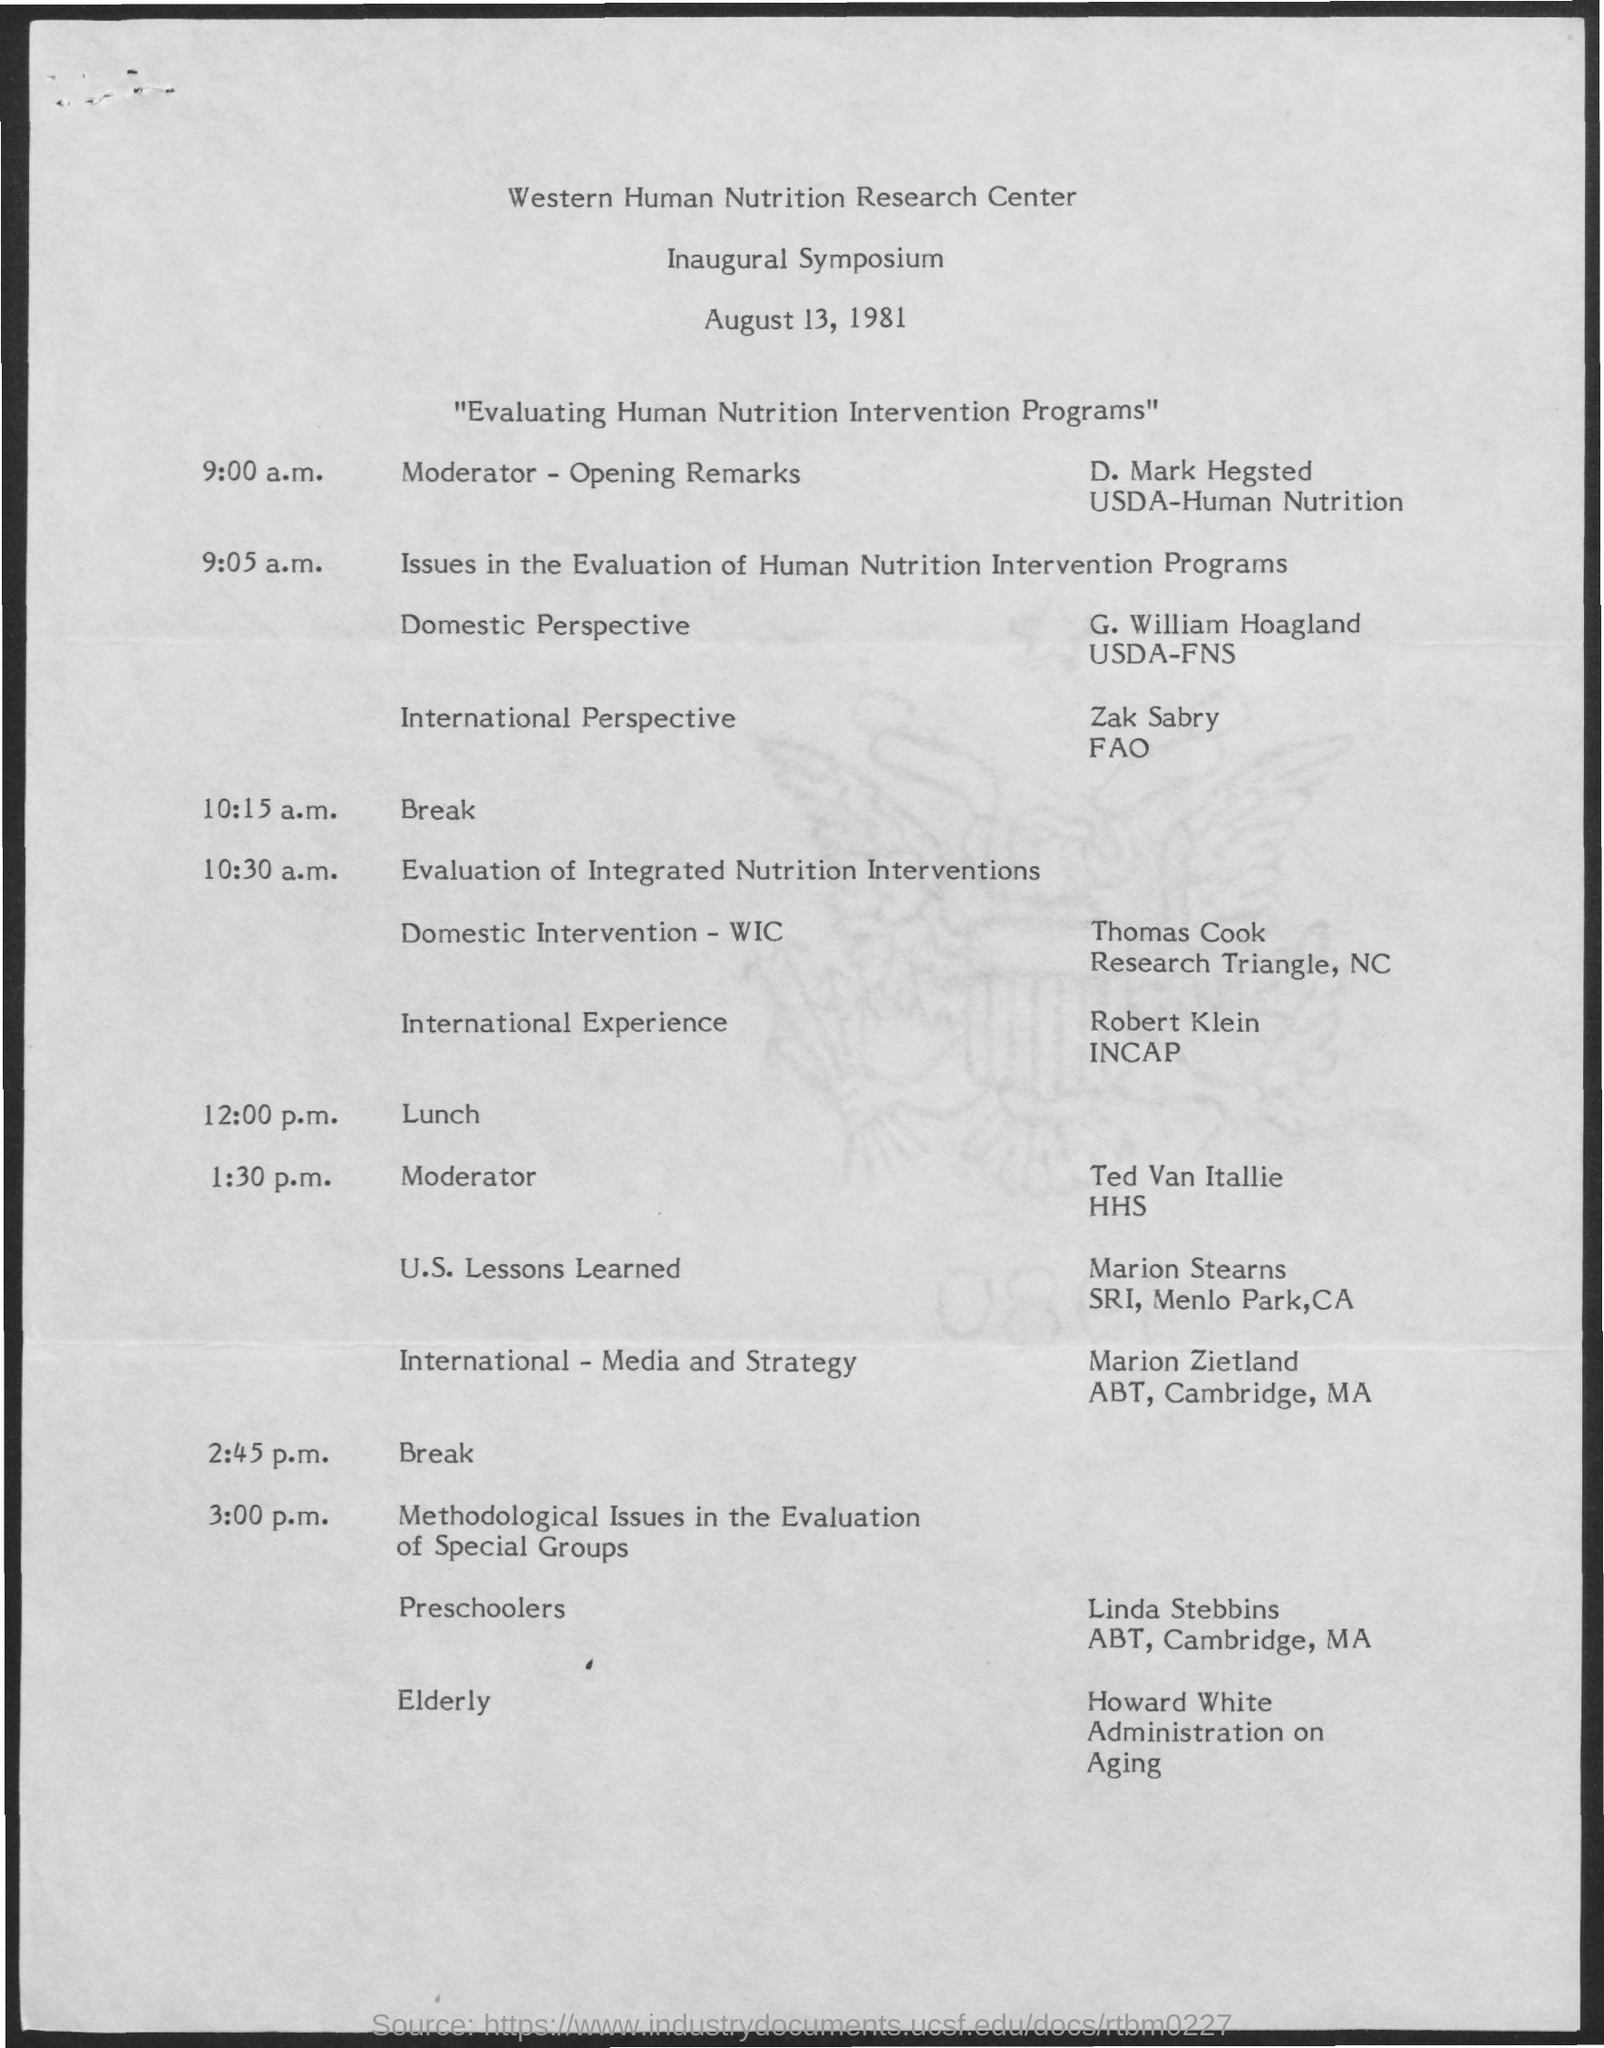Outline some significant characteristics in this image. The speaker of the topic "U.S. Lessons learned" is Marion Stearns. The Inaugural Symposium of the Western Human Nutrition Research Center took place on August 13, 1981. The moderator of the event was D. Mark Hegsted. The title of the symposium was 'Evaluating Human Nutrition Intervention Programs.' 